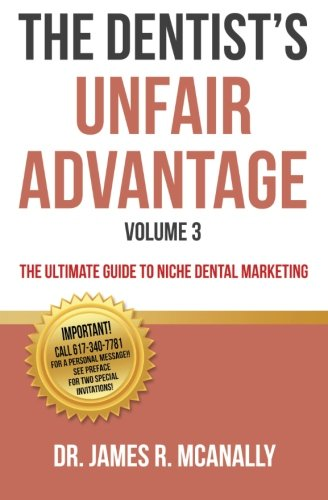What is the title of this book? The full title of this book is 'The Dentist's Unfair Advantage: The Ultimate Guide to Niche Dental Marketing', Volume 3. 